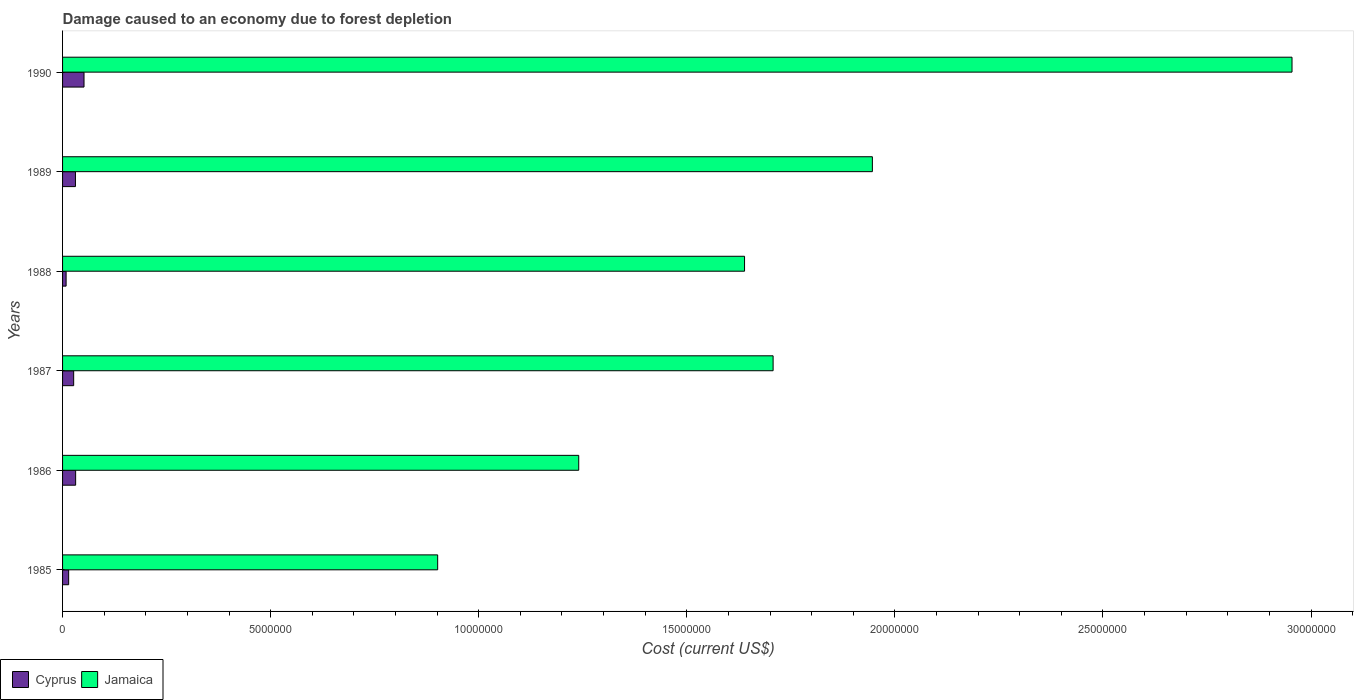How many different coloured bars are there?
Your answer should be compact. 2. How many groups of bars are there?
Provide a short and direct response. 6. Are the number of bars per tick equal to the number of legend labels?
Your answer should be very brief. Yes. Are the number of bars on each tick of the Y-axis equal?
Ensure brevity in your answer.  Yes. How many bars are there on the 4th tick from the bottom?
Offer a terse response. 2. What is the label of the 1st group of bars from the top?
Ensure brevity in your answer.  1990. In how many cases, is the number of bars for a given year not equal to the number of legend labels?
Offer a very short reply. 0. What is the cost of damage caused due to forest depletion in Jamaica in 1989?
Your response must be concise. 1.95e+07. Across all years, what is the maximum cost of damage caused due to forest depletion in Jamaica?
Offer a terse response. 2.95e+07. Across all years, what is the minimum cost of damage caused due to forest depletion in Jamaica?
Offer a very short reply. 9.01e+06. What is the total cost of damage caused due to forest depletion in Jamaica in the graph?
Ensure brevity in your answer.  1.04e+08. What is the difference between the cost of damage caused due to forest depletion in Jamaica in 1987 and that in 1990?
Offer a very short reply. -1.25e+07. What is the difference between the cost of damage caused due to forest depletion in Cyprus in 1990 and the cost of damage caused due to forest depletion in Jamaica in 1985?
Keep it short and to the point. -8.50e+06. What is the average cost of damage caused due to forest depletion in Cyprus per year?
Provide a succinct answer. 2.73e+05. In the year 1985, what is the difference between the cost of damage caused due to forest depletion in Jamaica and cost of damage caused due to forest depletion in Cyprus?
Ensure brevity in your answer.  8.87e+06. In how many years, is the cost of damage caused due to forest depletion in Jamaica greater than 3000000 US$?
Your answer should be very brief. 6. What is the ratio of the cost of damage caused due to forest depletion in Jamaica in 1985 to that in 1986?
Provide a short and direct response. 0.73. Is the cost of damage caused due to forest depletion in Jamaica in 1985 less than that in 1988?
Provide a short and direct response. Yes. Is the difference between the cost of damage caused due to forest depletion in Jamaica in 1986 and 1989 greater than the difference between the cost of damage caused due to forest depletion in Cyprus in 1986 and 1989?
Your answer should be compact. No. What is the difference between the highest and the second highest cost of damage caused due to forest depletion in Cyprus?
Keep it short and to the point. 2.01e+05. What is the difference between the highest and the lowest cost of damage caused due to forest depletion in Cyprus?
Ensure brevity in your answer.  4.30e+05. In how many years, is the cost of damage caused due to forest depletion in Cyprus greater than the average cost of damage caused due to forest depletion in Cyprus taken over all years?
Offer a very short reply. 3. What does the 1st bar from the top in 1986 represents?
Keep it short and to the point. Jamaica. What does the 1st bar from the bottom in 1990 represents?
Your response must be concise. Cyprus. How many bars are there?
Your answer should be very brief. 12. Are all the bars in the graph horizontal?
Your answer should be compact. Yes. How many years are there in the graph?
Your answer should be very brief. 6. What is the difference between two consecutive major ticks on the X-axis?
Give a very brief answer. 5.00e+06. Does the graph contain grids?
Offer a very short reply. No. Where does the legend appear in the graph?
Offer a terse response. Bottom left. How many legend labels are there?
Your answer should be very brief. 2. What is the title of the graph?
Offer a very short reply. Damage caused to an economy due to forest depletion. What is the label or title of the X-axis?
Provide a short and direct response. Cost (current US$). What is the label or title of the Y-axis?
Give a very brief answer. Years. What is the Cost (current US$) in Cyprus in 1985?
Your response must be concise. 1.46e+05. What is the Cost (current US$) of Jamaica in 1985?
Offer a very short reply. 9.01e+06. What is the Cost (current US$) in Cyprus in 1986?
Provide a succinct answer. 3.14e+05. What is the Cost (current US$) of Jamaica in 1986?
Offer a very short reply. 1.24e+07. What is the Cost (current US$) in Cyprus in 1987?
Offer a terse response. 2.67e+05. What is the Cost (current US$) in Jamaica in 1987?
Keep it short and to the point. 1.71e+07. What is the Cost (current US$) in Cyprus in 1988?
Your answer should be compact. 8.51e+04. What is the Cost (current US$) in Jamaica in 1988?
Offer a very short reply. 1.64e+07. What is the Cost (current US$) in Cyprus in 1989?
Your answer should be very brief. 3.10e+05. What is the Cost (current US$) of Jamaica in 1989?
Keep it short and to the point. 1.95e+07. What is the Cost (current US$) of Cyprus in 1990?
Offer a very short reply. 5.16e+05. What is the Cost (current US$) of Jamaica in 1990?
Your answer should be compact. 2.95e+07. Across all years, what is the maximum Cost (current US$) of Cyprus?
Make the answer very short. 5.16e+05. Across all years, what is the maximum Cost (current US$) in Jamaica?
Provide a short and direct response. 2.95e+07. Across all years, what is the minimum Cost (current US$) of Cyprus?
Give a very brief answer. 8.51e+04. Across all years, what is the minimum Cost (current US$) of Jamaica?
Provide a short and direct response. 9.01e+06. What is the total Cost (current US$) of Cyprus in the graph?
Provide a short and direct response. 1.64e+06. What is the total Cost (current US$) of Jamaica in the graph?
Offer a very short reply. 1.04e+08. What is the difference between the Cost (current US$) of Cyprus in 1985 and that in 1986?
Offer a very short reply. -1.68e+05. What is the difference between the Cost (current US$) of Jamaica in 1985 and that in 1986?
Give a very brief answer. -3.39e+06. What is the difference between the Cost (current US$) of Cyprus in 1985 and that in 1987?
Ensure brevity in your answer.  -1.20e+05. What is the difference between the Cost (current US$) in Jamaica in 1985 and that in 1987?
Provide a succinct answer. -8.06e+06. What is the difference between the Cost (current US$) in Cyprus in 1985 and that in 1988?
Your answer should be very brief. 6.13e+04. What is the difference between the Cost (current US$) in Jamaica in 1985 and that in 1988?
Offer a very short reply. -7.37e+06. What is the difference between the Cost (current US$) of Cyprus in 1985 and that in 1989?
Keep it short and to the point. -1.63e+05. What is the difference between the Cost (current US$) in Jamaica in 1985 and that in 1989?
Keep it short and to the point. -1.04e+07. What is the difference between the Cost (current US$) of Cyprus in 1985 and that in 1990?
Offer a very short reply. -3.69e+05. What is the difference between the Cost (current US$) in Jamaica in 1985 and that in 1990?
Offer a very short reply. -2.05e+07. What is the difference between the Cost (current US$) in Cyprus in 1986 and that in 1987?
Offer a very short reply. 4.73e+04. What is the difference between the Cost (current US$) of Jamaica in 1986 and that in 1987?
Your answer should be compact. -4.67e+06. What is the difference between the Cost (current US$) in Cyprus in 1986 and that in 1988?
Your answer should be compact. 2.29e+05. What is the difference between the Cost (current US$) of Jamaica in 1986 and that in 1988?
Your response must be concise. -3.98e+06. What is the difference between the Cost (current US$) of Cyprus in 1986 and that in 1989?
Your answer should be compact. 4549.1. What is the difference between the Cost (current US$) in Jamaica in 1986 and that in 1989?
Offer a very short reply. -7.06e+06. What is the difference between the Cost (current US$) in Cyprus in 1986 and that in 1990?
Give a very brief answer. -2.01e+05. What is the difference between the Cost (current US$) of Jamaica in 1986 and that in 1990?
Provide a short and direct response. -1.71e+07. What is the difference between the Cost (current US$) in Cyprus in 1987 and that in 1988?
Offer a terse response. 1.82e+05. What is the difference between the Cost (current US$) of Jamaica in 1987 and that in 1988?
Your answer should be very brief. 6.86e+05. What is the difference between the Cost (current US$) in Cyprus in 1987 and that in 1989?
Ensure brevity in your answer.  -4.28e+04. What is the difference between the Cost (current US$) of Jamaica in 1987 and that in 1989?
Your answer should be very brief. -2.39e+06. What is the difference between the Cost (current US$) of Cyprus in 1987 and that in 1990?
Offer a terse response. -2.49e+05. What is the difference between the Cost (current US$) in Jamaica in 1987 and that in 1990?
Ensure brevity in your answer.  -1.25e+07. What is the difference between the Cost (current US$) of Cyprus in 1988 and that in 1989?
Give a very brief answer. -2.24e+05. What is the difference between the Cost (current US$) of Jamaica in 1988 and that in 1989?
Keep it short and to the point. -3.07e+06. What is the difference between the Cost (current US$) in Cyprus in 1988 and that in 1990?
Provide a succinct answer. -4.30e+05. What is the difference between the Cost (current US$) of Jamaica in 1988 and that in 1990?
Offer a very short reply. -1.32e+07. What is the difference between the Cost (current US$) in Cyprus in 1989 and that in 1990?
Offer a terse response. -2.06e+05. What is the difference between the Cost (current US$) of Jamaica in 1989 and that in 1990?
Your response must be concise. -1.01e+07. What is the difference between the Cost (current US$) of Cyprus in 1985 and the Cost (current US$) of Jamaica in 1986?
Keep it short and to the point. -1.23e+07. What is the difference between the Cost (current US$) of Cyprus in 1985 and the Cost (current US$) of Jamaica in 1987?
Offer a very short reply. -1.69e+07. What is the difference between the Cost (current US$) of Cyprus in 1985 and the Cost (current US$) of Jamaica in 1988?
Your response must be concise. -1.62e+07. What is the difference between the Cost (current US$) of Cyprus in 1985 and the Cost (current US$) of Jamaica in 1989?
Offer a terse response. -1.93e+07. What is the difference between the Cost (current US$) of Cyprus in 1985 and the Cost (current US$) of Jamaica in 1990?
Provide a short and direct response. -2.94e+07. What is the difference between the Cost (current US$) of Cyprus in 1986 and the Cost (current US$) of Jamaica in 1987?
Make the answer very short. -1.68e+07. What is the difference between the Cost (current US$) of Cyprus in 1986 and the Cost (current US$) of Jamaica in 1988?
Provide a short and direct response. -1.61e+07. What is the difference between the Cost (current US$) of Cyprus in 1986 and the Cost (current US$) of Jamaica in 1989?
Your answer should be compact. -1.91e+07. What is the difference between the Cost (current US$) in Cyprus in 1986 and the Cost (current US$) in Jamaica in 1990?
Keep it short and to the point. -2.92e+07. What is the difference between the Cost (current US$) of Cyprus in 1987 and the Cost (current US$) of Jamaica in 1988?
Provide a succinct answer. -1.61e+07. What is the difference between the Cost (current US$) in Cyprus in 1987 and the Cost (current US$) in Jamaica in 1989?
Offer a very short reply. -1.92e+07. What is the difference between the Cost (current US$) of Cyprus in 1987 and the Cost (current US$) of Jamaica in 1990?
Provide a short and direct response. -2.93e+07. What is the difference between the Cost (current US$) of Cyprus in 1988 and the Cost (current US$) of Jamaica in 1989?
Your response must be concise. -1.94e+07. What is the difference between the Cost (current US$) of Cyprus in 1988 and the Cost (current US$) of Jamaica in 1990?
Your answer should be very brief. -2.95e+07. What is the difference between the Cost (current US$) of Cyprus in 1989 and the Cost (current US$) of Jamaica in 1990?
Provide a short and direct response. -2.92e+07. What is the average Cost (current US$) in Cyprus per year?
Offer a terse response. 2.73e+05. What is the average Cost (current US$) of Jamaica per year?
Your answer should be compact. 1.73e+07. In the year 1985, what is the difference between the Cost (current US$) in Cyprus and Cost (current US$) in Jamaica?
Offer a very short reply. -8.87e+06. In the year 1986, what is the difference between the Cost (current US$) in Cyprus and Cost (current US$) in Jamaica?
Keep it short and to the point. -1.21e+07. In the year 1987, what is the difference between the Cost (current US$) of Cyprus and Cost (current US$) of Jamaica?
Make the answer very short. -1.68e+07. In the year 1988, what is the difference between the Cost (current US$) in Cyprus and Cost (current US$) in Jamaica?
Ensure brevity in your answer.  -1.63e+07. In the year 1989, what is the difference between the Cost (current US$) in Cyprus and Cost (current US$) in Jamaica?
Ensure brevity in your answer.  -1.91e+07. In the year 1990, what is the difference between the Cost (current US$) of Cyprus and Cost (current US$) of Jamaica?
Make the answer very short. -2.90e+07. What is the ratio of the Cost (current US$) in Cyprus in 1985 to that in 1986?
Provide a succinct answer. 0.47. What is the ratio of the Cost (current US$) of Jamaica in 1985 to that in 1986?
Offer a terse response. 0.73. What is the ratio of the Cost (current US$) of Cyprus in 1985 to that in 1987?
Give a very brief answer. 0.55. What is the ratio of the Cost (current US$) in Jamaica in 1985 to that in 1987?
Offer a terse response. 0.53. What is the ratio of the Cost (current US$) in Cyprus in 1985 to that in 1988?
Offer a terse response. 1.72. What is the ratio of the Cost (current US$) in Jamaica in 1985 to that in 1988?
Make the answer very short. 0.55. What is the ratio of the Cost (current US$) in Cyprus in 1985 to that in 1989?
Keep it short and to the point. 0.47. What is the ratio of the Cost (current US$) of Jamaica in 1985 to that in 1989?
Make the answer very short. 0.46. What is the ratio of the Cost (current US$) of Cyprus in 1985 to that in 1990?
Your answer should be very brief. 0.28. What is the ratio of the Cost (current US$) of Jamaica in 1985 to that in 1990?
Ensure brevity in your answer.  0.31. What is the ratio of the Cost (current US$) in Cyprus in 1986 to that in 1987?
Your answer should be very brief. 1.18. What is the ratio of the Cost (current US$) in Jamaica in 1986 to that in 1987?
Your answer should be very brief. 0.73. What is the ratio of the Cost (current US$) in Cyprus in 1986 to that in 1988?
Your answer should be very brief. 3.69. What is the ratio of the Cost (current US$) of Jamaica in 1986 to that in 1988?
Provide a succinct answer. 0.76. What is the ratio of the Cost (current US$) in Cyprus in 1986 to that in 1989?
Your response must be concise. 1.01. What is the ratio of the Cost (current US$) in Jamaica in 1986 to that in 1989?
Make the answer very short. 0.64. What is the ratio of the Cost (current US$) in Cyprus in 1986 to that in 1990?
Give a very brief answer. 0.61. What is the ratio of the Cost (current US$) of Jamaica in 1986 to that in 1990?
Give a very brief answer. 0.42. What is the ratio of the Cost (current US$) in Cyprus in 1987 to that in 1988?
Make the answer very short. 3.13. What is the ratio of the Cost (current US$) in Jamaica in 1987 to that in 1988?
Ensure brevity in your answer.  1.04. What is the ratio of the Cost (current US$) in Cyprus in 1987 to that in 1989?
Give a very brief answer. 0.86. What is the ratio of the Cost (current US$) of Jamaica in 1987 to that in 1989?
Provide a short and direct response. 0.88. What is the ratio of the Cost (current US$) in Cyprus in 1987 to that in 1990?
Offer a very short reply. 0.52. What is the ratio of the Cost (current US$) of Jamaica in 1987 to that in 1990?
Provide a short and direct response. 0.58. What is the ratio of the Cost (current US$) of Cyprus in 1988 to that in 1989?
Give a very brief answer. 0.28. What is the ratio of the Cost (current US$) of Jamaica in 1988 to that in 1989?
Your answer should be very brief. 0.84. What is the ratio of the Cost (current US$) of Cyprus in 1988 to that in 1990?
Offer a terse response. 0.17. What is the ratio of the Cost (current US$) in Jamaica in 1988 to that in 1990?
Provide a short and direct response. 0.55. What is the ratio of the Cost (current US$) in Cyprus in 1989 to that in 1990?
Give a very brief answer. 0.6. What is the ratio of the Cost (current US$) of Jamaica in 1989 to that in 1990?
Make the answer very short. 0.66. What is the difference between the highest and the second highest Cost (current US$) of Cyprus?
Provide a succinct answer. 2.01e+05. What is the difference between the highest and the second highest Cost (current US$) in Jamaica?
Offer a terse response. 1.01e+07. What is the difference between the highest and the lowest Cost (current US$) of Cyprus?
Offer a very short reply. 4.30e+05. What is the difference between the highest and the lowest Cost (current US$) in Jamaica?
Your answer should be compact. 2.05e+07. 